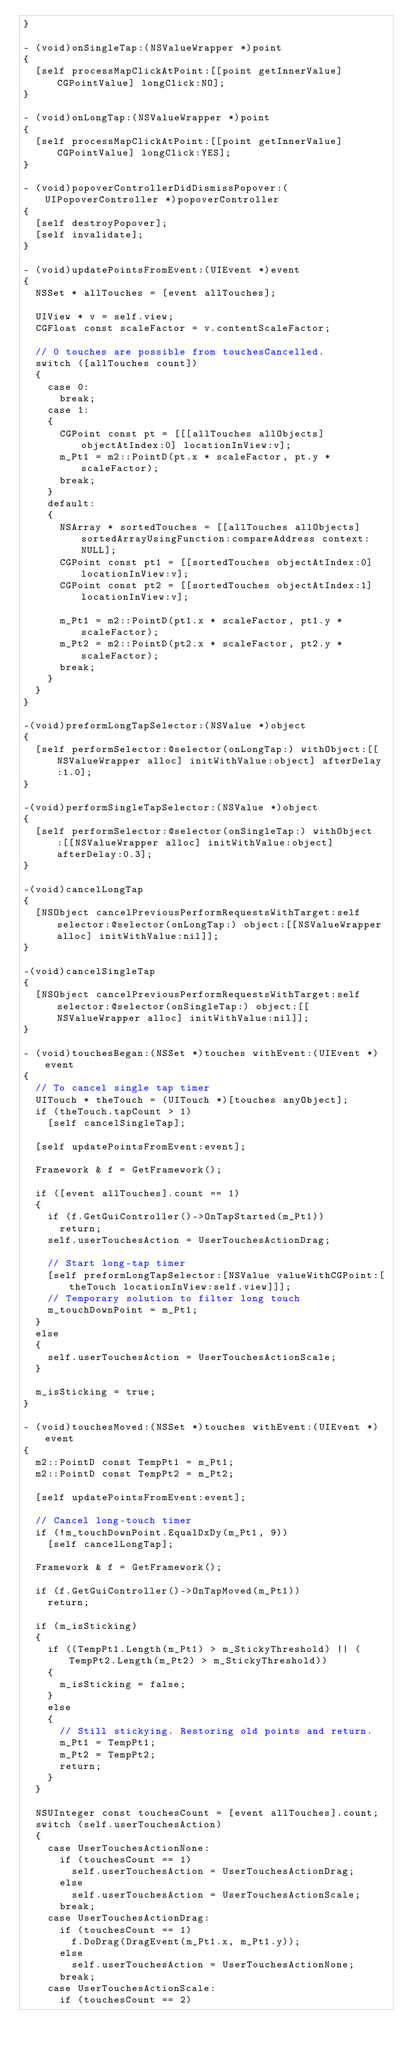Convert code to text. <code><loc_0><loc_0><loc_500><loc_500><_ObjectiveC_>}

- (void)onSingleTap:(NSValueWrapper *)point
{
  [self processMapClickAtPoint:[[point getInnerValue] CGPointValue] longClick:NO];
}

- (void)onLongTap:(NSValueWrapper *)point
{
  [self processMapClickAtPoint:[[point getInnerValue] CGPointValue] longClick:YES];
}

- (void)popoverControllerDidDismissPopover:(UIPopoverController *)popoverController
{
  [self destroyPopover];
  [self invalidate];
}

- (void)updatePointsFromEvent:(UIEvent *)event
{
  NSSet * allTouches = [event allTouches];

  UIView * v = self.view;
  CGFloat const scaleFactor = v.contentScaleFactor;

  // 0 touches are possible from touchesCancelled.
  switch ([allTouches count])
  {
    case 0:
      break;
    case 1:
    {
      CGPoint const pt = [[[allTouches allObjects] objectAtIndex:0] locationInView:v];
      m_Pt1 = m2::PointD(pt.x * scaleFactor, pt.y * scaleFactor);
      break;
    }
    default:
    {
      NSArray * sortedTouches = [[allTouches allObjects] sortedArrayUsingFunction:compareAddress context:NULL];
      CGPoint const pt1 = [[sortedTouches objectAtIndex:0] locationInView:v];
      CGPoint const pt2 = [[sortedTouches objectAtIndex:1] locationInView:v];

      m_Pt1 = m2::PointD(pt1.x * scaleFactor, pt1.y * scaleFactor);
      m_Pt2 = m2::PointD(pt2.x * scaleFactor, pt2.y * scaleFactor);
      break;
    }
  }
}

-(void)preformLongTapSelector:(NSValue *)object
{
  [self performSelector:@selector(onLongTap:) withObject:[[NSValueWrapper alloc] initWithValue:object] afterDelay:1.0];
}

-(void)performSingleTapSelector:(NSValue *)object
{
  [self performSelector:@selector(onSingleTap:) withObject:[[NSValueWrapper alloc] initWithValue:object] afterDelay:0.3];
}

-(void)cancelLongTap
{
  [NSObject cancelPreviousPerformRequestsWithTarget:self selector:@selector(onLongTap:) object:[[NSValueWrapper alloc] initWithValue:nil]];
}

-(void)cancelSingleTap
{
  [NSObject cancelPreviousPerformRequestsWithTarget:self selector:@selector(onSingleTap:) object:[[NSValueWrapper alloc] initWithValue:nil]];
}

- (void)touchesBegan:(NSSet *)touches withEvent:(UIEvent *)event
{
  // To cancel single tap timer
  UITouch * theTouch = (UITouch *)[touches anyObject];
  if (theTouch.tapCount > 1)
    [self cancelSingleTap];

  [self updatePointsFromEvent:event];

  Framework & f = GetFramework();

  if ([event allTouches].count == 1)
  {
    if (f.GetGuiController()->OnTapStarted(m_Pt1))
      return;
    self.userTouchesAction = UserTouchesActionDrag;

    // Start long-tap timer
    [self preformLongTapSelector:[NSValue valueWithCGPoint:[theTouch locationInView:self.view]]];
    // Temporary solution to filter long touch
    m_touchDownPoint = m_Pt1;
  }
  else
  {
    self.userTouchesAction = UserTouchesActionScale;
  }

  m_isSticking = true;
}

- (void)touchesMoved:(NSSet *)touches withEvent:(UIEvent *)event
{
  m2::PointD const TempPt1 = m_Pt1;
  m2::PointD const TempPt2 = m_Pt2;

  [self updatePointsFromEvent:event];

  // Cancel long-touch timer
  if (!m_touchDownPoint.EqualDxDy(m_Pt1, 9))
    [self cancelLongTap];

  Framework & f = GetFramework();

  if (f.GetGuiController()->OnTapMoved(m_Pt1))
    return;

  if (m_isSticking)
  {
    if ((TempPt1.Length(m_Pt1) > m_StickyThreshold) || (TempPt2.Length(m_Pt2) > m_StickyThreshold))
    {
      m_isSticking = false;
    }
    else
    {
      // Still stickying. Restoring old points and return.
      m_Pt1 = TempPt1;
      m_Pt2 = TempPt2;
      return;
    }
  }

  NSUInteger const touchesCount = [event allTouches].count;
  switch (self.userTouchesAction)
  {
    case UserTouchesActionNone:
      if (touchesCount == 1)
        self.userTouchesAction = UserTouchesActionDrag;
      else
        self.userTouchesAction = UserTouchesActionScale;
      break;
    case UserTouchesActionDrag:
      if (touchesCount == 1)
        f.DoDrag(DragEvent(m_Pt1.x, m_Pt1.y));
      else
        self.userTouchesAction = UserTouchesActionNone;
      break;
    case UserTouchesActionScale:
      if (touchesCount == 2)</code> 